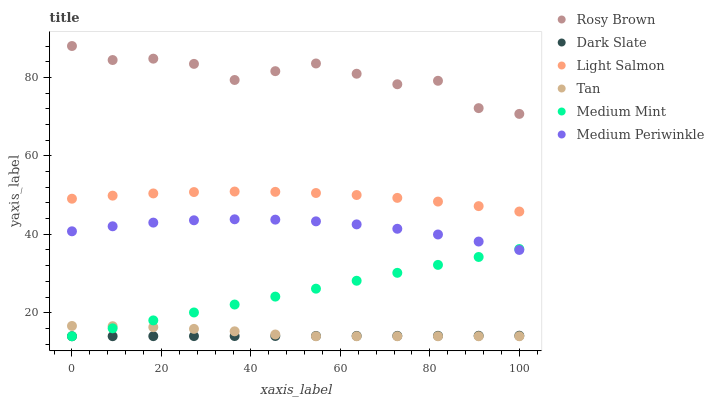Does Dark Slate have the minimum area under the curve?
Answer yes or no. Yes. Does Rosy Brown have the maximum area under the curve?
Answer yes or no. Yes. Does Light Salmon have the minimum area under the curve?
Answer yes or no. No. Does Light Salmon have the maximum area under the curve?
Answer yes or no. No. Is Dark Slate the smoothest?
Answer yes or no. Yes. Is Rosy Brown the roughest?
Answer yes or no. Yes. Is Light Salmon the smoothest?
Answer yes or no. No. Is Light Salmon the roughest?
Answer yes or no. No. Does Medium Mint have the lowest value?
Answer yes or no. Yes. Does Light Salmon have the lowest value?
Answer yes or no. No. Does Rosy Brown have the highest value?
Answer yes or no. Yes. Does Light Salmon have the highest value?
Answer yes or no. No. Is Tan less than Rosy Brown?
Answer yes or no. Yes. Is Light Salmon greater than Dark Slate?
Answer yes or no. Yes. Does Medium Mint intersect Dark Slate?
Answer yes or no. Yes. Is Medium Mint less than Dark Slate?
Answer yes or no. No. Is Medium Mint greater than Dark Slate?
Answer yes or no. No. Does Tan intersect Rosy Brown?
Answer yes or no. No. 